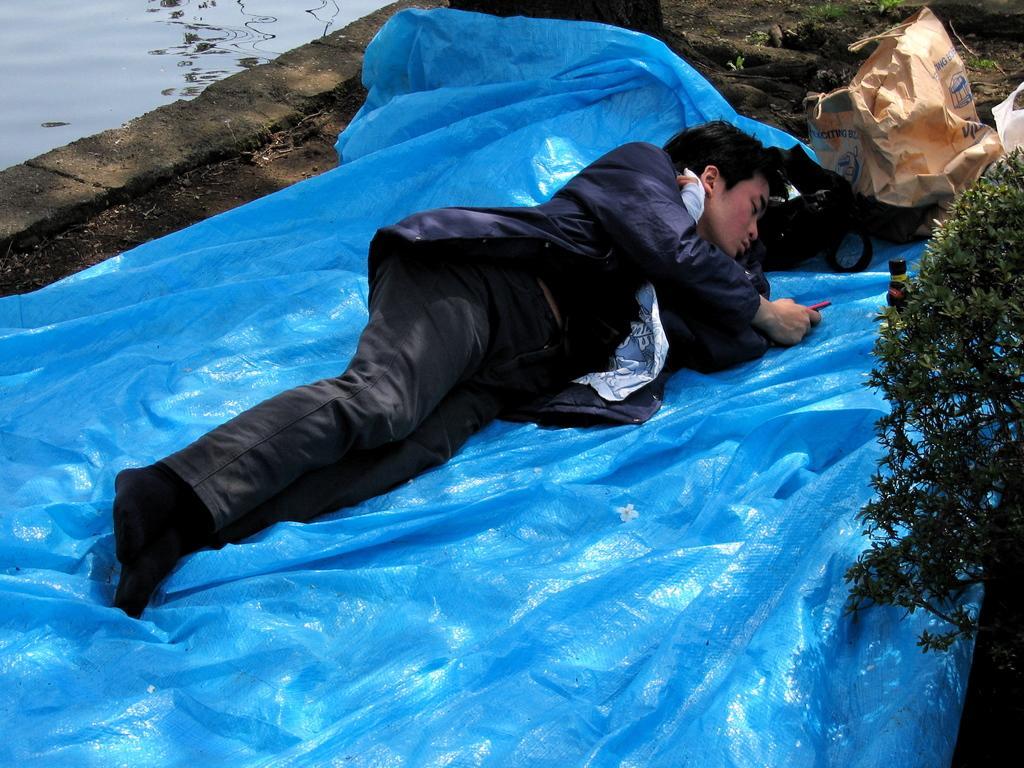Could you give a brief overview of what you see in this image? In the center of the image we can see a man lying on the sheet. On the right there is a plant. In the background we can see covers. On the left there is water. 